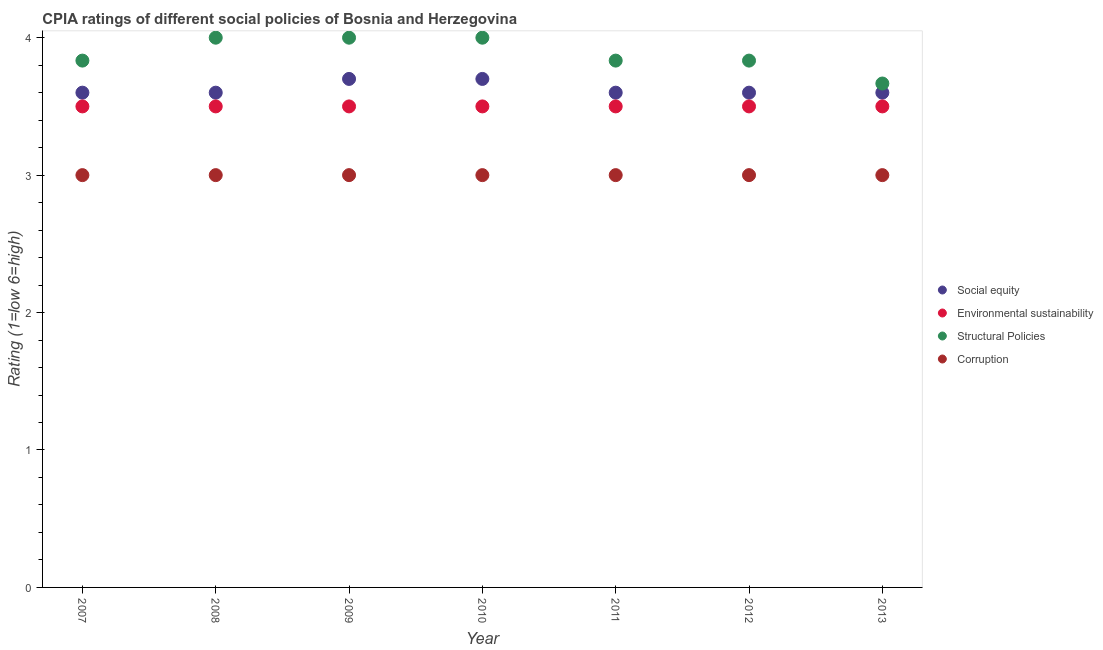Across all years, what is the maximum cpia rating of environmental sustainability?
Make the answer very short. 3.5. Across all years, what is the minimum cpia rating of environmental sustainability?
Your response must be concise. 3.5. What is the total cpia rating of social equity in the graph?
Give a very brief answer. 25.4. What is the difference between the cpia rating of environmental sustainability in 2008 and that in 2012?
Provide a succinct answer. 0. What is the difference between the cpia rating of corruption in 2013 and the cpia rating of social equity in 2009?
Offer a terse response. -0.7. What is the average cpia rating of social equity per year?
Offer a very short reply. 3.63. In the year 2008, what is the difference between the cpia rating of environmental sustainability and cpia rating of corruption?
Provide a succinct answer. 0.5. What is the ratio of the cpia rating of social equity in 2009 to that in 2013?
Offer a very short reply. 1.03. What is the difference between the highest and the lowest cpia rating of structural policies?
Keep it short and to the point. 0.33. In how many years, is the cpia rating of structural policies greater than the average cpia rating of structural policies taken over all years?
Your answer should be very brief. 3. Is the sum of the cpia rating of social equity in 2007 and 2009 greater than the maximum cpia rating of environmental sustainability across all years?
Your response must be concise. Yes. Does the cpia rating of social equity monotonically increase over the years?
Provide a succinct answer. No. How many dotlines are there?
Your response must be concise. 4. How many years are there in the graph?
Ensure brevity in your answer.  7. What is the difference between two consecutive major ticks on the Y-axis?
Your answer should be very brief. 1. Does the graph contain any zero values?
Ensure brevity in your answer.  No. Does the graph contain grids?
Offer a very short reply. No. How many legend labels are there?
Ensure brevity in your answer.  4. What is the title of the graph?
Your response must be concise. CPIA ratings of different social policies of Bosnia and Herzegovina. Does "Secondary general education" appear as one of the legend labels in the graph?
Offer a terse response. No. What is the label or title of the Y-axis?
Offer a very short reply. Rating (1=low 6=high). What is the Rating (1=low 6=high) of Social equity in 2007?
Provide a short and direct response. 3.6. What is the Rating (1=low 6=high) in Structural Policies in 2007?
Provide a succinct answer. 3.83. What is the Rating (1=low 6=high) of Corruption in 2007?
Keep it short and to the point. 3. What is the Rating (1=low 6=high) of Environmental sustainability in 2008?
Make the answer very short. 3.5. What is the Rating (1=low 6=high) in Corruption in 2008?
Offer a very short reply. 3. What is the Rating (1=low 6=high) of Social equity in 2009?
Offer a terse response. 3.7. What is the Rating (1=low 6=high) of Environmental sustainability in 2009?
Provide a short and direct response. 3.5. What is the Rating (1=low 6=high) in Structural Policies in 2009?
Your answer should be very brief. 4. What is the Rating (1=low 6=high) of Corruption in 2009?
Provide a short and direct response. 3. What is the Rating (1=low 6=high) of Environmental sustainability in 2010?
Provide a short and direct response. 3.5. What is the Rating (1=low 6=high) in Structural Policies in 2010?
Keep it short and to the point. 4. What is the Rating (1=low 6=high) in Corruption in 2010?
Your answer should be compact. 3. What is the Rating (1=low 6=high) in Environmental sustainability in 2011?
Your answer should be compact. 3.5. What is the Rating (1=low 6=high) in Structural Policies in 2011?
Your answer should be very brief. 3.83. What is the Rating (1=low 6=high) of Social equity in 2012?
Keep it short and to the point. 3.6. What is the Rating (1=low 6=high) of Structural Policies in 2012?
Give a very brief answer. 3.83. What is the Rating (1=low 6=high) in Social equity in 2013?
Keep it short and to the point. 3.6. What is the Rating (1=low 6=high) of Structural Policies in 2013?
Your answer should be very brief. 3.67. What is the Rating (1=low 6=high) of Corruption in 2013?
Offer a terse response. 3. Across all years, what is the minimum Rating (1=low 6=high) in Environmental sustainability?
Your answer should be very brief. 3.5. Across all years, what is the minimum Rating (1=low 6=high) in Structural Policies?
Your answer should be very brief. 3.67. Across all years, what is the minimum Rating (1=low 6=high) of Corruption?
Your answer should be compact. 3. What is the total Rating (1=low 6=high) of Social equity in the graph?
Offer a very short reply. 25.4. What is the total Rating (1=low 6=high) of Structural Policies in the graph?
Ensure brevity in your answer.  27.17. What is the difference between the Rating (1=low 6=high) of Social equity in 2007 and that in 2008?
Keep it short and to the point. 0. What is the difference between the Rating (1=low 6=high) in Social equity in 2007 and that in 2009?
Your answer should be very brief. -0.1. What is the difference between the Rating (1=low 6=high) in Environmental sustainability in 2007 and that in 2009?
Provide a succinct answer. 0. What is the difference between the Rating (1=low 6=high) of Social equity in 2007 and that in 2010?
Offer a terse response. -0.1. What is the difference between the Rating (1=low 6=high) of Structural Policies in 2007 and that in 2010?
Your response must be concise. -0.17. What is the difference between the Rating (1=low 6=high) in Corruption in 2007 and that in 2010?
Ensure brevity in your answer.  0. What is the difference between the Rating (1=low 6=high) in Social equity in 2007 and that in 2011?
Make the answer very short. 0. What is the difference between the Rating (1=low 6=high) of Structural Policies in 2007 and that in 2011?
Provide a short and direct response. 0. What is the difference between the Rating (1=low 6=high) in Corruption in 2007 and that in 2011?
Ensure brevity in your answer.  0. What is the difference between the Rating (1=low 6=high) of Social equity in 2007 and that in 2012?
Give a very brief answer. 0. What is the difference between the Rating (1=low 6=high) of Structural Policies in 2007 and that in 2012?
Keep it short and to the point. 0. What is the difference between the Rating (1=low 6=high) of Social equity in 2007 and that in 2013?
Give a very brief answer. 0. What is the difference between the Rating (1=low 6=high) of Environmental sustainability in 2007 and that in 2013?
Ensure brevity in your answer.  0. What is the difference between the Rating (1=low 6=high) of Structural Policies in 2007 and that in 2013?
Provide a succinct answer. 0.17. What is the difference between the Rating (1=low 6=high) in Social equity in 2008 and that in 2009?
Offer a very short reply. -0.1. What is the difference between the Rating (1=low 6=high) in Environmental sustainability in 2008 and that in 2009?
Keep it short and to the point. 0. What is the difference between the Rating (1=low 6=high) of Structural Policies in 2008 and that in 2009?
Make the answer very short. 0. What is the difference between the Rating (1=low 6=high) of Social equity in 2008 and that in 2010?
Offer a very short reply. -0.1. What is the difference between the Rating (1=low 6=high) of Structural Policies in 2008 and that in 2011?
Make the answer very short. 0.17. What is the difference between the Rating (1=low 6=high) in Corruption in 2008 and that in 2011?
Make the answer very short. 0. What is the difference between the Rating (1=low 6=high) of Environmental sustainability in 2008 and that in 2012?
Ensure brevity in your answer.  0. What is the difference between the Rating (1=low 6=high) of Corruption in 2008 and that in 2012?
Your answer should be compact. 0. What is the difference between the Rating (1=low 6=high) in Social equity in 2008 and that in 2013?
Give a very brief answer. 0. What is the difference between the Rating (1=low 6=high) of Environmental sustainability in 2008 and that in 2013?
Your response must be concise. 0. What is the difference between the Rating (1=low 6=high) in Corruption in 2008 and that in 2013?
Provide a short and direct response. 0. What is the difference between the Rating (1=low 6=high) of Environmental sustainability in 2009 and that in 2010?
Your answer should be very brief. 0. What is the difference between the Rating (1=low 6=high) in Structural Policies in 2009 and that in 2010?
Keep it short and to the point. 0. What is the difference between the Rating (1=low 6=high) in Social equity in 2009 and that in 2011?
Provide a short and direct response. 0.1. What is the difference between the Rating (1=low 6=high) in Corruption in 2009 and that in 2011?
Offer a very short reply. 0. What is the difference between the Rating (1=low 6=high) in Social equity in 2009 and that in 2012?
Your answer should be very brief. 0.1. What is the difference between the Rating (1=low 6=high) in Environmental sustainability in 2009 and that in 2012?
Your answer should be very brief. 0. What is the difference between the Rating (1=low 6=high) of Structural Policies in 2009 and that in 2013?
Ensure brevity in your answer.  0.33. What is the difference between the Rating (1=low 6=high) in Social equity in 2010 and that in 2011?
Your answer should be very brief. 0.1. What is the difference between the Rating (1=low 6=high) of Corruption in 2010 and that in 2011?
Offer a terse response. 0. What is the difference between the Rating (1=low 6=high) of Social equity in 2010 and that in 2012?
Offer a very short reply. 0.1. What is the difference between the Rating (1=low 6=high) of Environmental sustainability in 2010 and that in 2012?
Your answer should be very brief. 0. What is the difference between the Rating (1=low 6=high) in Structural Policies in 2010 and that in 2012?
Provide a short and direct response. 0.17. What is the difference between the Rating (1=low 6=high) of Corruption in 2010 and that in 2012?
Ensure brevity in your answer.  0. What is the difference between the Rating (1=low 6=high) in Environmental sustainability in 2010 and that in 2013?
Offer a very short reply. 0. What is the difference between the Rating (1=low 6=high) of Corruption in 2010 and that in 2013?
Ensure brevity in your answer.  0. What is the difference between the Rating (1=low 6=high) in Environmental sustainability in 2011 and that in 2012?
Your answer should be very brief. 0. What is the difference between the Rating (1=low 6=high) of Structural Policies in 2011 and that in 2012?
Make the answer very short. 0. What is the difference between the Rating (1=low 6=high) in Environmental sustainability in 2011 and that in 2013?
Provide a short and direct response. 0. What is the difference between the Rating (1=low 6=high) in Structural Policies in 2011 and that in 2013?
Your answer should be compact. 0.17. What is the difference between the Rating (1=low 6=high) of Corruption in 2011 and that in 2013?
Provide a succinct answer. 0. What is the difference between the Rating (1=low 6=high) of Structural Policies in 2012 and that in 2013?
Provide a short and direct response. 0.17. What is the difference between the Rating (1=low 6=high) in Social equity in 2007 and the Rating (1=low 6=high) in Environmental sustainability in 2008?
Give a very brief answer. 0.1. What is the difference between the Rating (1=low 6=high) of Social equity in 2007 and the Rating (1=low 6=high) of Corruption in 2008?
Give a very brief answer. 0.6. What is the difference between the Rating (1=low 6=high) of Structural Policies in 2007 and the Rating (1=low 6=high) of Corruption in 2008?
Provide a short and direct response. 0.83. What is the difference between the Rating (1=low 6=high) of Social equity in 2007 and the Rating (1=low 6=high) of Environmental sustainability in 2009?
Your answer should be compact. 0.1. What is the difference between the Rating (1=low 6=high) in Social equity in 2007 and the Rating (1=low 6=high) in Structural Policies in 2009?
Your response must be concise. -0.4. What is the difference between the Rating (1=low 6=high) of Environmental sustainability in 2007 and the Rating (1=low 6=high) of Structural Policies in 2009?
Ensure brevity in your answer.  -0.5. What is the difference between the Rating (1=low 6=high) in Structural Policies in 2007 and the Rating (1=low 6=high) in Corruption in 2009?
Offer a terse response. 0.83. What is the difference between the Rating (1=low 6=high) in Social equity in 2007 and the Rating (1=low 6=high) in Environmental sustainability in 2010?
Your response must be concise. 0.1. What is the difference between the Rating (1=low 6=high) in Social equity in 2007 and the Rating (1=low 6=high) in Structural Policies in 2010?
Your answer should be compact. -0.4. What is the difference between the Rating (1=low 6=high) of Social equity in 2007 and the Rating (1=low 6=high) of Corruption in 2010?
Give a very brief answer. 0.6. What is the difference between the Rating (1=low 6=high) in Environmental sustainability in 2007 and the Rating (1=low 6=high) in Structural Policies in 2010?
Your answer should be compact. -0.5. What is the difference between the Rating (1=low 6=high) of Structural Policies in 2007 and the Rating (1=low 6=high) of Corruption in 2010?
Give a very brief answer. 0.83. What is the difference between the Rating (1=low 6=high) of Social equity in 2007 and the Rating (1=low 6=high) of Environmental sustainability in 2011?
Provide a short and direct response. 0.1. What is the difference between the Rating (1=low 6=high) of Social equity in 2007 and the Rating (1=low 6=high) of Structural Policies in 2011?
Ensure brevity in your answer.  -0.23. What is the difference between the Rating (1=low 6=high) in Social equity in 2007 and the Rating (1=low 6=high) in Corruption in 2011?
Ensure brevity in your answer.  0.6. What is the difference between the Rating (1=low 6=high) of Social equity in 2007 and the Rating (1=low 6=high) of Environmental sustainability in 2012?
Give a very brief answer. 0.1. What is the difference between the Rating (1=low 6=high) of Social equity in 2007 and the Rating (1=low 6=high) of Structural Policies in 2012?
Your answer should be very brief. -0.23. What is the difference between the Rating (1=low 6=high) of Structural Policies in 2007 and the Rating (1=low 6=high) of Corruption in 2012?
Provide a short and direct response. 0.83. What is the difference between the Rating (1=low 6=high) in Social equity in 2007 and the Rating (1=low 6=high) in Structural Policies in 2013?
Give a very brief answer. -0.07. What is the difference between the Rating (1=low 6=high) in Social equity in 2007 and the Rating (1=low 6=high) in Corruption in 2013?
Your answer should be compact. 0.6. What is the difference between the Rating (1=low 6=high) in Social equity in 2008 and the Rating (1=low 6=high) in Structural Policies in 2009?
Offer a terse response. -0.4. What is the difference between the Rating (1=low 6=high) in Environmental sustainability in 2008 and the Rating (1=low 6=high) in Structural Policies in 2009?
Your answer should be compact. -0.5. What is the difference between the Rating (1=low 6=high) of Structural Policies in 2008 and the Rating (1=low 6=high) of Corruption in 2009?
Offer a very short reply. 1. What is the difference between the Rating (1=low 6=high) in Social equity in 2008 and the Rating (1=low 6=high) in Structural Policies in 2010?
Offer a terse response. -0.4. What is the difference between the Rating (1=low 6=high) of Environmental sustainability in 2008 and the Rating (1=low 6=high) of Structural Policies in 2010?
Offer a terse response. -0.5. What is the difference between the Rating (1=low 6=high) in Environmental sustainability in 2008 and the Rating (1=low 6=high) in Corruption in 2010?
Ensure brevity in your answer.  0.5. What is the difference between the Rating (1=low 6=high) in Social equity in 2008 and the Rating (1=low 6=high) in Structural Policies in 2011?
Offer a terse response. -0.23. What is the difference between the Rating (1=low 6=high) in Environmental sustainability in 2008 and the Rating (1=low 6=high) in Structural Policies in 2011?
Ensure brevity in your answer.  -0.33. What is the difference between the Rating (1=low 6=high) in Structural Policies in 2008 and the Rating (1=low 6=high) in Corruption in 2011?
Keep it short and to the point. 1. What is the difference between the Rating (1=low 6=high) of Social equity in 2008 and the Rating (1=low 6=high) of Structural Policies in 2012?
Give a very brief answer. -0.23. What is the difference between the Rating (1=low 6=high) in Environmental sustainability in 2008 and the Rating (1=low 6=high) in Corruption in 2012?
Ensure brevity in your answer.  0.5. What is the difference between the Rating (1=low 6=high) of Structural Policies in 2008 and the Rating (1=low 6=high) of Corruption in 2012?
Give a very brief answer. 1. What is the difference between the Rating (1=low 6=high) in Social equity in 2008 and the Rating (1=low 6=high) in Environmental sustainability in 2013?
Your answer should be compact. 0.1. What is the difference between the Rating (1=low 6=high) of Social equity in 2008 and the Rating (1=low 6=high) of Structural Policies in 2013?
Provide a succinct answer. -0.07. What is the difference between the Rating (1=low 6=high) in Social equity in 2009 and the Rating (1=low 6=high) in Corruption in 2010?
Give a very brief answer. 0.7. What is the difference between the Rating (1=low 6=high) of Environmental sustainability in 2009 and the Rating (1=low 6=high) of Structural Policies in 2010?
Provide a short and direct response. -0.5. What is the difference between the Rating (1=low 6=high) in Environmental sustainability in 2009 and the Rating (1=low 6=high) in Corruption in 2010?
Your answer should be very brief. 0.5. What is the difference between the Rating (1=low 6=high) in Structural Policies in 2009 and the Rating (1=low 6=high) in Corruption in 2010?
Give a very brief answer. 1. What is the difference between the Rating (1=low 6=high) in Social equity in 2009 and the Rating (1=low 6=high) in Environmental sustainability in 2011?
Give a very brief answer. 0.2. What is the difference between the Rating (1=low 6=high) in Social equity in 2009 and the Rating (1=low 6=high) in Structural Policies in 2011?
Your answer should be very brief. -0.13. What is the difference between the Rating (1=low 6=high) in Social equity in 2009 and the Rating (1=low 6=high) in Corruption in 2011?
Your answer should be very brief. 0.7. What is the difference between the Rating (1=low 6=high) in Environmental sustainability in 2009 and the Rating (1=low 6=high) in Corruption in 2011?
Provide a succinct answer. 0.5. What is the difference between the Rating (1=low 6=high) of Social equity in 2009 and the Rating (1=low 6=high) of Structural Policies in 2012?
Offer a very short reply. -0.13. What is the difference between the Rating (1=low 6=high) in Social equity in 2009 and the Rating (1=low 6=high) in Corruption in 2012?
Make the answer very short. 0.7. What is the difference between the Rating (1=low 6=high) of Social equity in 2009 and the Rating (1=low 6=high) of Environmental sustainability in 2013?
Your answer should be very brief. 0.2. What is the difference between the Rating (1=low 6=high) in Social equity in 2009 and the Rating (1=low 6=high) in Corruption in 2013?
Provide a short and direct response. 0.7. What is the difference between the Rating (1=low 6=high) of Environmental sustainability in 2009 and the Rating (1=low 6=high) of Corruption in 2013?
Ensure brevity in your answer.  0.5. What is the difference between the Rating (1=low 6=high) in Social equity in 2010 and the Rating (1=low 6=high) in Structural Policies in 2011?
Ensure brevity in your answer.  -0.13. What is the difference between the Rating (1=low 6=high) in Social equity in 2010 and the Rating (1=low 6=high) in Corruption in 2011?
Make the answer very short. 0.7. What is the difference between the Rating (1=low 6=high) in Environmental sustainability in 2010 and the Rating (1=low 6=high) in Corruption in 2011?
Ensure brevity in your answer.  0.5. What is the difference between the Rating (1=low 6=high) in Structural Policies in 2010 and the Rating (1=low 6=high) in Corruption in 2011?
Your answer should be compact. 1. What is the difference between the Rating (1=low 6=high) of Social equity in 2010 and the Rating (1=low 6=high) of Environmental sustainability in 2012?
Provide a short and direct response. 0.2. What is the difference between the Rating (1=low 6=high) in Social equity in 2010 and the Rating (1=low 6=high) in Structural Policies in 2012?
Offer a very short reply. -0.13. What is the difference between the Rating (1=low 6=high) in Social equity in 2010 and the Rating (1=low 6=high) in Corruption in 2012?
Ensure brevity in your answer.  0.7. What is the difference between the Rating (1=low 6=high) of Environmental sustainability in 2010 and the Rating (1=low 6=high) of Structural Policies in 2012?
Offer a very short reply. -0.33. What is the difference between the Rating (1=low 6=high) in Structural Policies in 2010 and the Rating (1=low 6=high) in Corruption in 2012?
Your answer should be very brief. 1. What is the difference between the Rating (1=low 6=high) in Social equity in 2010 and the Rating (1=low 6=high) in Environmental sustainability in 2013?
Your response must be concise. 0.2. What is the difference between the Rating (1=low 6=high) in Environmental sustainability in 2010 and the Rating (1=low 6=high) in Structural Policies in 2013?
Give a very brief answer. -0.17. What is the difference between the Rating (1=low 6=high) of Social equity in 2011 and the Rating (1=low 6=high) of Structural Policies in 2012?
Your response must be concise. -0.23. What is the difference between the Rating (1=low 6=high) in Environmental sustainability in 2011 and the Rating (1=low 6=high) in Corruption in 2012?
Make the answer very short. 0.5. What is the difference between the Rating (1=low 6=high) in Social equity in 2011 and the Rating (1=low 6=high) in Structural Policies in 2013?
Keep it short and to the point. -0.07. What is the difference between the Rating (1=low 6=high) of Social equity in 2011 and the Rating (1=low 6=high) of Corruption in 2013?
Offer a terse response. 0.6. What is the difference between the Rating (1=low 6=high) of Environmental sustainability in 2011 and the Rating (1=low 6=high) of Structural Policies in 2013?
Give a very brief answer. -0.17. What is the difference between the Rating (1=low 6=high) in Social equity in 2012 and the Rating (1=low 6=high) in Structural Policies in 2013?
Offer a terse response. -0.07. What is the difference between the Rating (1=low 6=high) of Environmental sustainability in 2012 and the Rating (1=low 6=high) of Structural Policies in 2013?
Offer a very short reply. -0.17. What is the difference between the Rating (1=low 6=high) of Environmental sustainability in 2012 and the Rating (1=low 6=high) of Corruption in 2013?
Provide a short and direct response. 0.5. What is the difference between the Rating (1=low 6=high) in Structural Policies in 2012 and the Rating (1=low 6=high) in Corruption in 2013?
Keep it short and to the point. 0.83. What is the average Rating (1=low 6=high) of Social equity per year?
Ensure brevity in your answer.  3.63. What is the average Rating (1=low 6=high) of Structural Policies per year?
Your response must be concise. 3.88. What is the average Rating (1=low 6=high) in Corruption per year?
Provide a succinct answer. 3. In the year 2007, what is the difference between the Rating (1=low 6=high) in Social equity and Rating (1=low 6=high) in Environmental sustainability?
Provide a succinct answer. 0.1. In the year 2007, what is the difference between the Rating (1=low 6=high) in Social equity and Rating (1=low 6=high) in Structural Policies?
Provide a succinct answer. -0.23. In the year 2008, what is the difference between the Rating (1=low 6=high) in Environmental sustainability and Rating (1=low 6=high) in Corruption?
Your answer should be very brief. 0.5. In the year 2008, what is the difference between the Rating (1=low 6=high) in Structural Policies and Rating (1=low 6=high) in Corruption?
Your response must be concise. 1. In the year 2009, what is the difference between the Rating (1=low 6=high) in Social equity and Rating (1=low 6=high) in Structural Policies?
Offer a terse response. -0.3. In the year 2009, what is the difference between the Rating (1=low 6=high) of Social equity and Rating (1=low 6=high) of Corruption?
Provide a succinct answer. 0.7. In the year 2009, what is the difference between the Rating (1=low 6=high) of Environmental sustainability and Rating (1=low 6=high) of Structural Policies?
Offer a terse response. -0.5. In the year 2010, what is the difference between the Rating (1=low 6=high) in Social equity and Rating (1=low 6=high) in Environmental sustainability?
Your answer should be very brief. 0.2. In the year 2010, what is the difference between the Rating (1=low 6=high) in Social equity and Rating (1=low 6=high) in Structural Policies?
Your response must be concise. -0.3. In the year 2010, what is the difference between the Rating (1=low 6=high) in Social equity and Rating (1=low 6=high) in Corruption?
Offer a very short reply. 0.7. In the year 2010, what is the difference between the Rating (1=low 6=high) in Environmental sustainability and Rating (1=low 6=high) in Structural Policies?
Make the answer very short. -0.5. In the year 2010, what is the difference between the Rating (1=low 6=high) of Environmental sustainability and Rating (1=low 6=high) of Corruption?
Make the answer very short. 0.5. In the year 2010, what is the difference between the Rating (1=low 6=high) of Structural Policies and Rating (1=low 6=high) of Corruption?
Offer a very short reply. 1. In the year 2011, what is the difference between the Rating (1=low 6=high) in Social equity and Rating (1=low 6=high) in Structural Policies?
Your answer should be compact. -0.23. In the year 2011, what is the difference between the Rating (1=low 6=high) in Environmental sustainability and Rating (1=low 6=high) in Corruption?
Your answer should be compact. 0.5. In the year 2012, what is the difference between the Rating (1=low 6=high) of Social equity and Rating (1=low 6=high) of Environmental sustainability?
Your answer should be very brief. 0.1. In the year 2012, what is the difference between the Rating (1=low 6=high) in Social equity and Rating (1=low 6=high) in Structural Policies?
Offer a very short reply. -0.23. In the year 2013, what is the difference between the Rating (1=low 6=high) in Social equity and Rating (1=low 6=high) in Structural Policies?
Your response must be concise. -0.07. In the year 2013, what is the difference between the Rating (1=low 6=high) of Structural Policies and Rating (1=low 6=high) of Corruption?
Your answer should be compact. 0.67. What is the ratio of the Rating (1=low 6=high) in Social equity in 2007 to that in 2008?
Offer a very short reply. 1. What is the ratio of the Rating (1=low 6=high) of Environmental sustainability in 2007 to that in 2008?
Offer a very short reply. 1. What is the ratio of the Rating (1=low 6=high) in Structural Policies in 2007 to that in 2008?
Provide a succinct answer. 0.96. What is the ratio of the Rating (1=low 6=high) of Corruption in 2007 to that in 2008?
Your answer should be compact. 1. What is the ratio of the Rating (1=low 6=high) of Social equity in 2007 to that in 2009?
Your answer should be compact. 0.97. What is the ratio of the Rating (1=low 6=high) in Structural Policies in 2007 to that in 2009?
Make the answer very short. 0.96. What is the ratio of the Rating (1=low 6=high) in Social equity in 2007 to that in 2010?
Your answer should be very brief. 0.97. What is the ratio of the Rating (1=low 6=high) of Social equity in 2007 to that in 2012?
Provide a short and direct response. 1. What is the ratio of the Rating (1=low 6=high) of Environmental sustainability in 2007 to that in 2012?
Provide a short and direct response. 1. What is the ratio of the Rating (1=low 6=high) in Structural Policies in 2007 to that in 2012?
Your answer should be compact. 1. What is the ratio of the Rating (1=low 6=high) in Corruption in 2007 to that in 2012?
Offer a terse response. 1. What is the ratio of the Rating (1=low 6=high) of Social equity in 2007 to that in 2013?
Ensure brevity in your answer.  1. What is the ratio of the Rating (1=low 6=high) in Structural Policies in 2007 to that in 2013?
Give a very brief answer. 1.05. What is the ratio of the Rating (1=low 6=high) of Corruption in 2007 to that in 2013?
Your answer should be very brief. 1. What is the ratio of the Rating (1=low 6=high) in Corruption in 2008 to that in 2009?
Give a very brief answer. 1. What is the ratio of the Rating (1=low 6=high) in Environmental sustainability in 2008 to that in 2010?
Offer a terse response. 1. What is the ratio of the Rating (1=low 6=high) in Environmental sustainability in 2008 to that in 2011?
Keep it short and to the point. 1. What is the ratio of the Rating (1=low 6=high) in Structural Policies in 2008 to that in 2011?
Your response must be concise. 1.04. What is the ratio of the Rating (1=low 6=high) in Social equity in 2008 to that in 2012?
Your response must be concise. 1. What is the ratio of the Rating (1=low 6=high) of Environmental sustainability in 2008 to that in 2012?
Give a very brief answer. 1. What is the ratio of the Rating (1=low 6=high) of Structural Policies in 2008 to that in 2012?
Your response must be concise. 1.04. What is the ratio of the Rating (1=low 6=high) in Corruption in 2008 to that in 2012?
Your response must be concise. 1. What is the ratio of the Rating (1=low 6=high) in Environmental sustainability in 2009 to that in 2010?
Offer a very short reply. 1. What is the ratio of the Rating (1=low 6=high) in Structural Policies in 2009 to that in 2010?
Provide a short and direct response. 1. What is the ratio of the Rating (1=low 6=high) in Social equity in 2009 to that in 2011?
Provide a short and direct response. 1.03. What is the ratio of the Rating (1=low 6=high) in Structural Policies in 2009 to that in 2011?
Ensure brevity in your answer.  1.04. What is the ratio of the Rating (1=low 6=high) of Corruption in 2009 to that in 2011?
Your answer should be very brief. 1. What is the ratio of the Rating (1=low 6=high) of Social equity in 2009 to that in 2012?
Offer a very short reply. 1.03. What is the ratio of the Rating (1=low 6=high) of Structural Policies in 2009 to that in 2012?
Provide a short and direct response. 1.04. What is the ratio of the Rating (1=low 6=high) in Corruption in 2009 to that in 2012?
Keep it short and to the point. 1. What is the ratio of the Rating (1=low 6=high) of Social equity in 2009 to that in 2013?
Provide a short and direct response. 1.03. What is the ratio of the Rating (1=low 6=high) of Environmental sustainability in 2009 to that in 2013?
Give a very brief answer. 1. What is the ratio of the Rating (1=low 6=high) of Social equity in 2010 to that in 2011?
Offer a very short reply. 1.03. What is the ratio of the Rating (1=low 6=high) of Structural Policies in 2010 to that in 2011?
Provide a succinct answer. 1.04. What is the ratio of the Rating (1=low 6=high) in Corruption in 2010 to that in 2011?
Your answer should be very brief. 1. What is the ratio of the Rating (1=low 6=high) of Social equity in 2010 to that in 2012?
Offer a terse response. 1.03. What is the ratio of the Rating (1=low 6=high) of Structural Policies in 2010 to that in 2012?
Your answer should be compact. 1.04. What is the ratio of the Rating (1=low 6=high) of Corruption in 2010 to that in 2012?
Your answer should be compact. 1. What is the ratio of the Rating (1=low 6=high) of Social equity in 2010 to that in 2013?
Offer a terse response. 1.03. What is the ratio of the Rating (1=low 6=high) in Structural Policies in 2010 to that in 2013?
Keep it short and to the point. 1.09. What is the ratio of the Rating (1=low 6=high) in Social equity in 2011 to that in 2012?
Offer a terse response. 1. What is the ratio of the Rating (1=low 6=high) of Social equity in 2011 to that in 2013?
Give a very brief answer. 1. What is the ratio of the Rating (1=low 6=high) of Environmental sustainability in 2011 to that in 2013?
Make the answer very short. 1. What is the ratio of the Rating (1=low 6=high) of Structural Policies in 2011 to that in 2013?
Keep it short and to the point. 1.05. What is the ratio of the Rating (1=low 6=high) of Structural Policies in 2012 to that in 2013?
Ensure brevity in your answer.  1.05. What is the difference between the highest and the second highest Rating (1=low 6=high) of Structural Policies?
Your answer should be very brief. 0. What is the difference between the highest and the second highest Rating (1=low 6=high) in Corruption?
Your answer should be compact. 0. What is the difference between the highest and the lowest Rating (1=low 6=high) of Environmental sustainability?
Give a very brief answer. 0. What is the difference between the highest and the lowest Rating (1=low 6=high) in Corruption?
Provide a short and direct response. 0. 